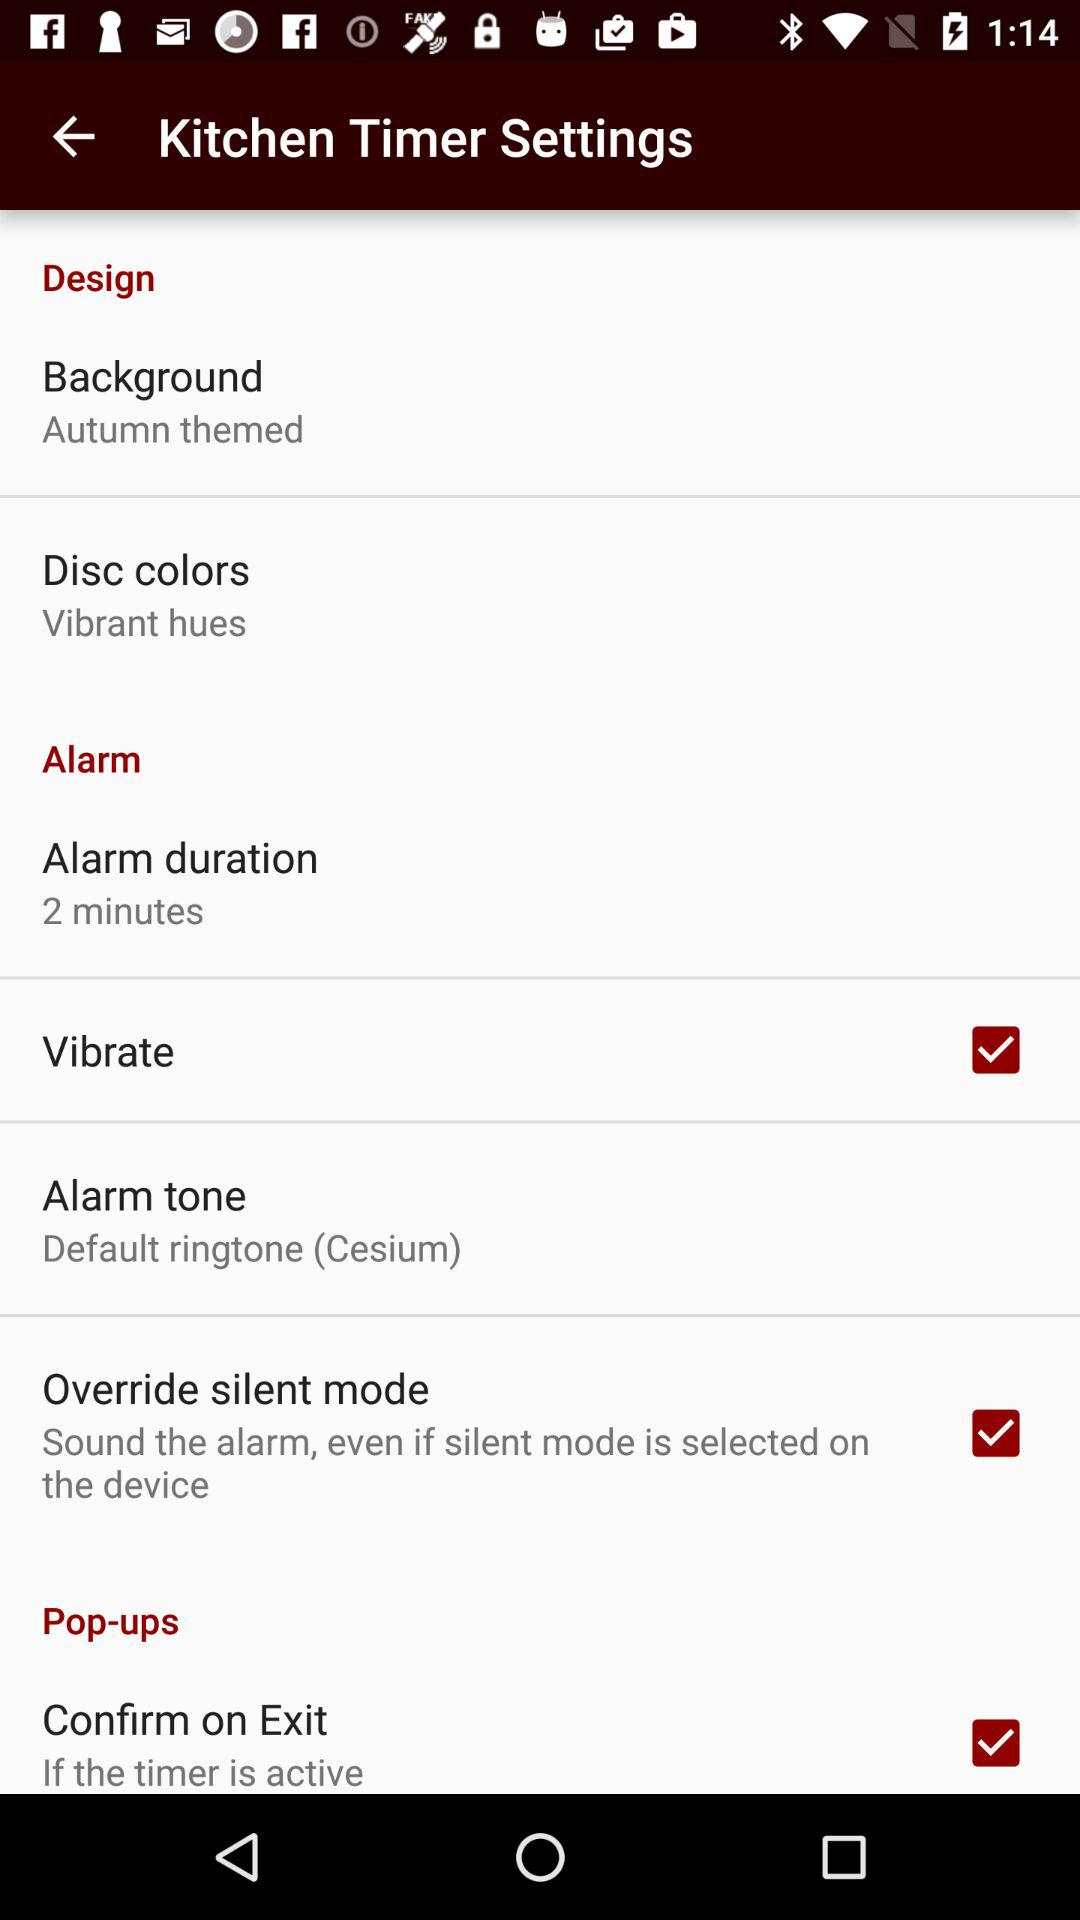What are the disc colors? The disc colors are vibrant hues. 